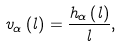Convert formula to latex. <formula><loc_0><loc_0><loc_500><loc_500>v _ { \alpha } \left ( l \right ) = \frac { h _ { \alpha } \left ( l \right ) } { l } ,</formula> 